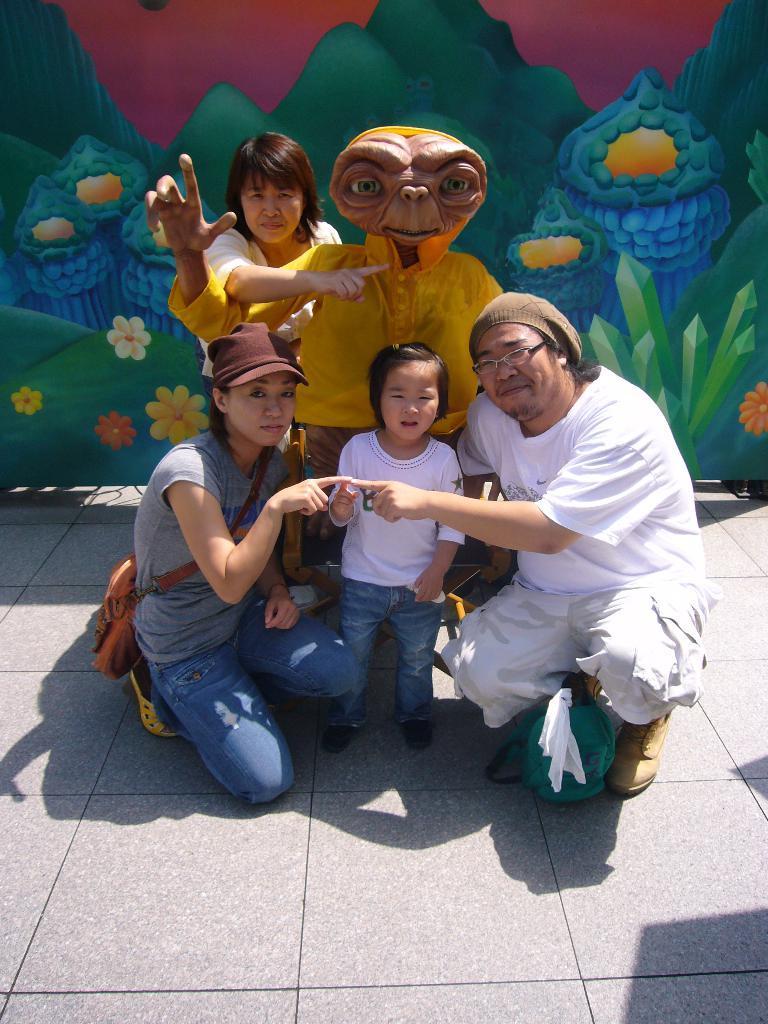Please provide a concise description of this image. In this picture we can see a statue and four people on the ground. In the background we can see painting on the wall. 